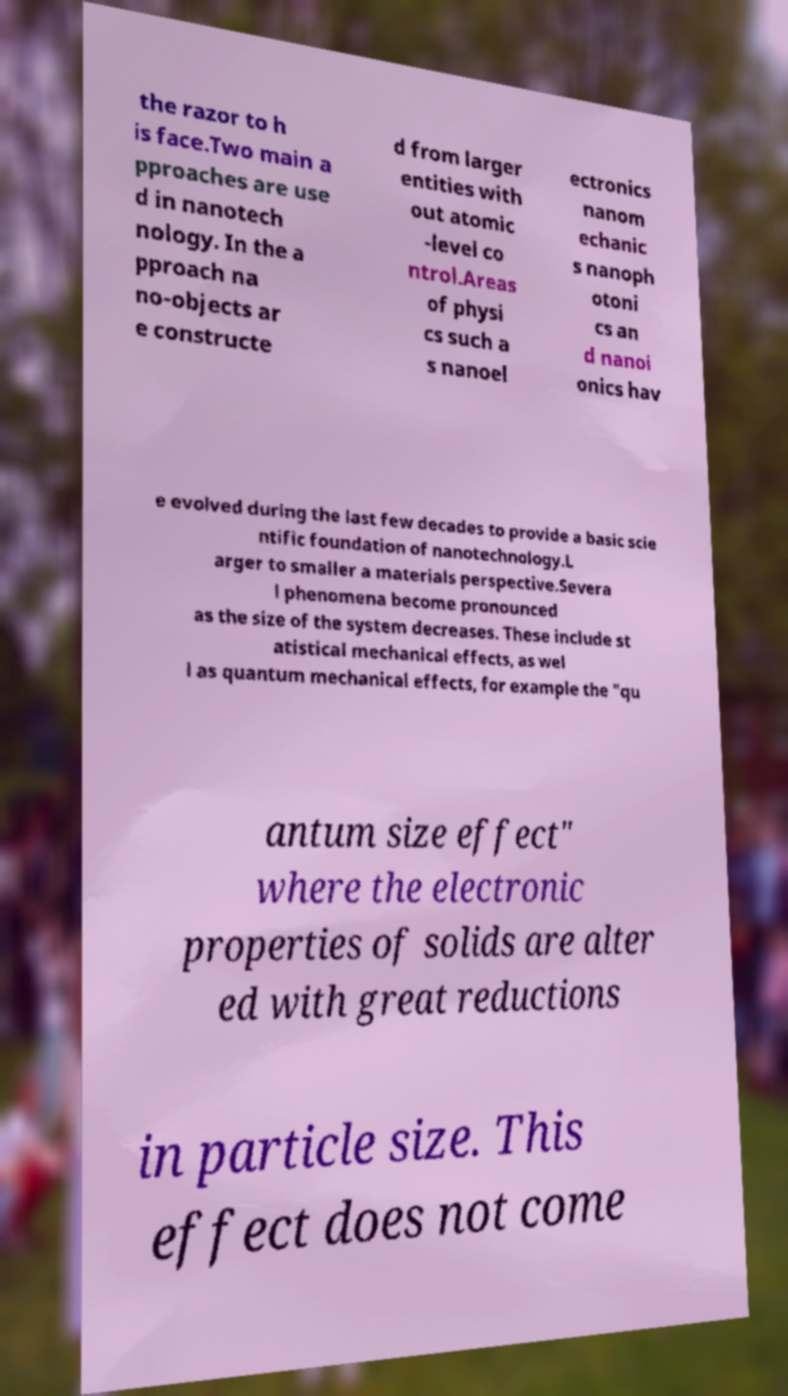Please identify and transcribe the text found in this image. the razor to h is face.Two main a pproaches are use d in nanotech nology. In the a pproach na no-objects ar e constructe d from larger entities with out atomic -level co ntrol.Areas of physi cs such a s nanoel ectronics nanom echanic s nanoph otoni cs an d nanoi onics hav e evolved during the last few decades to provide a basic scie ntific foundation of nanotechnology.L arger to smaller a materials perspective.Severa l phenomena become pronounced as the size of the system decreases. These include st atistical mechanical effects, as wel l as quantum mechanical effects, for example the "qu antum size effect" where the electronic properties of solids are alter ed with great reductions in particle size. This effect does not come 